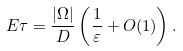<formula> <loc_0><loc_0><loc_500><loc_500>E \tau = \frac { | \Omega | } { D } \left ( \frac { 1 } { \varepsilon } + O ( 1 ) \right ) .</formula> 